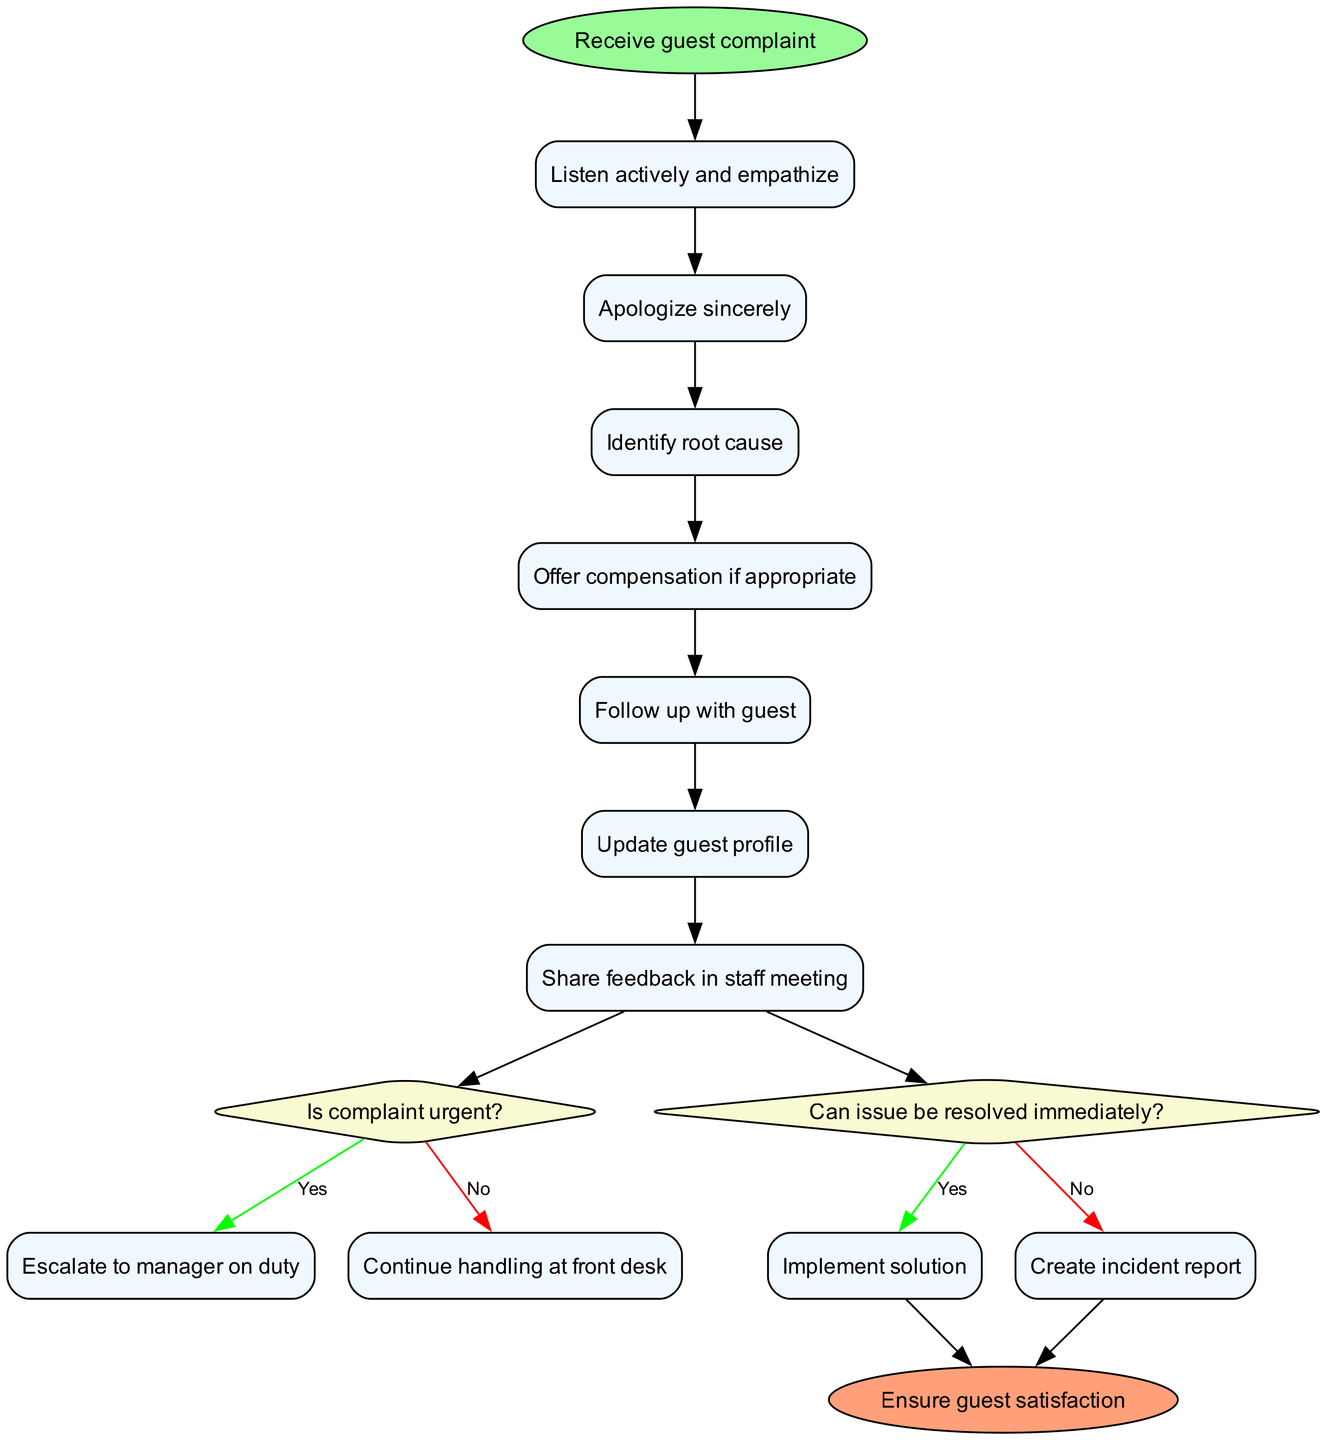What is the starting point of the diagram? The starting point of the diagram is labeled "Receive guest complaint". This can be found as the sole starting node at the top of the flowchart.
Answer: Receive guest complaint How many actions are listed in the flowchart? The flowchart contains a total of 7 actions that describe how to handle guest complaints. This can be counted by reviewing the action nodes in the diagram.
Answer: 7 What do you do if the complaint is urgent? If the complaint is urgent, the flowchart specifies to "Escalate to manager on duty". This is indicated under the decision node that asks if the complaint is urgent.
Answer: Escalate to manager on duty What follows after listening actively and empathizing with the guest? The next action after "Listen actively and empathize" is to "Apologize sincerely", which is denoted by the connection from the first action node to the second action node.
Answer: Apologize sincerely What happens if the issue cannot be resolved immediately? If the issue cannot be resolved immediately, the flowchart states to "Create incident report". This is derived from the second decision node asking if the issue can be resolved immediately.
Answer: Create incident report Which action includes following up with the guest? The action that includes following up with the guest is labeled "Follow up with guest". This can be found among the listed actions in the flowchart.
Answer: Follow up with guest Where does the flowchart end? The flowchart ends at the node labeled "Ensure guest satisfaction". This is indicated as the final node connected to the decision paths leading to it.
Answer: Ensure guest satisfaction What is the second decision node's condition? The second decision node's condition is "Can issue be resolved immediately?". This can be found as the diamond-shaped node in the flowchart after the actions.
Answer: Can issue be resolved immediately What color is the start node of the flowchart? The start node of the flowchart is colored light green, specifically labeled with the color code that is used for starting points in such diagrams.
Answer: Light green 